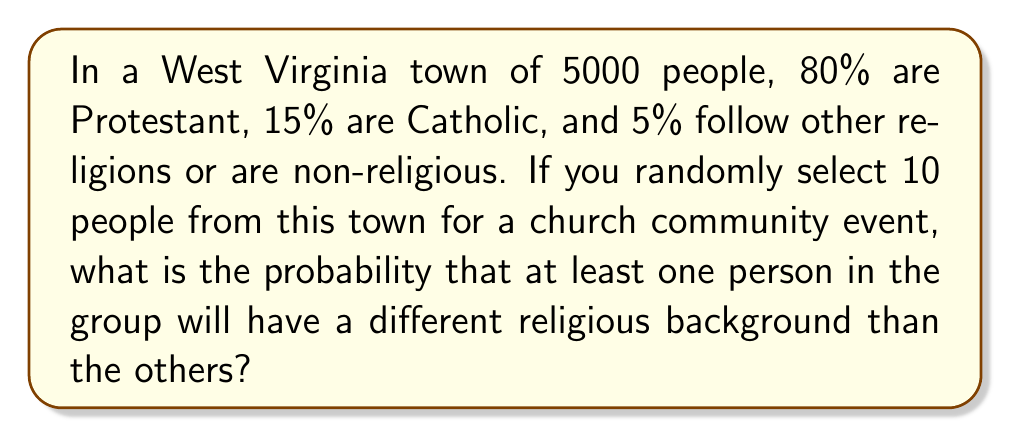Give your solution to this math problem. Let's approach this step-by-step:

1) First, we need to calculate the probability of all 10 people having the same religious background. We'll do this for each group:

   For Protestants: $P(\text{all Protestant}) = 0.80^{10}$
   For Catholics: $P(\text{all Catholic}) = 0.15^{10}$
   For others: $P(\text{all others}) = 0.05^{10}$

2) Now, let's calculate these probabilities:

   $P(\text{all Protestant}) = 0.80^{10} \approx 0.1074$
   $P(\text{all Catholic}) = 0.15^{10} \approx 5.7665 \times 10^{-8}$
   $P(\text{all others}) = 0.05^{10} \approx 9.7656 \times 10^{-14}$

3) The probability of all 10 people having the same religious background is the sum of these probabilities:

   $P(\text{all same}) = 0.1074 + 5.7665 \times 10^{-8} + 9.7656 \times 10^{-14} \approx 0.1074$

4) Therefore, the probability of at least one person having a different religious background is the complement of this probability:

   $P(\text{at least one different}) = 1 - P(\text{all same}) = 1 - 0.1074 = 0.8926$

5) Converting to a percentage:

   $0.8926 \times 100\% = 89.26\%$
Answer: 89.26% 